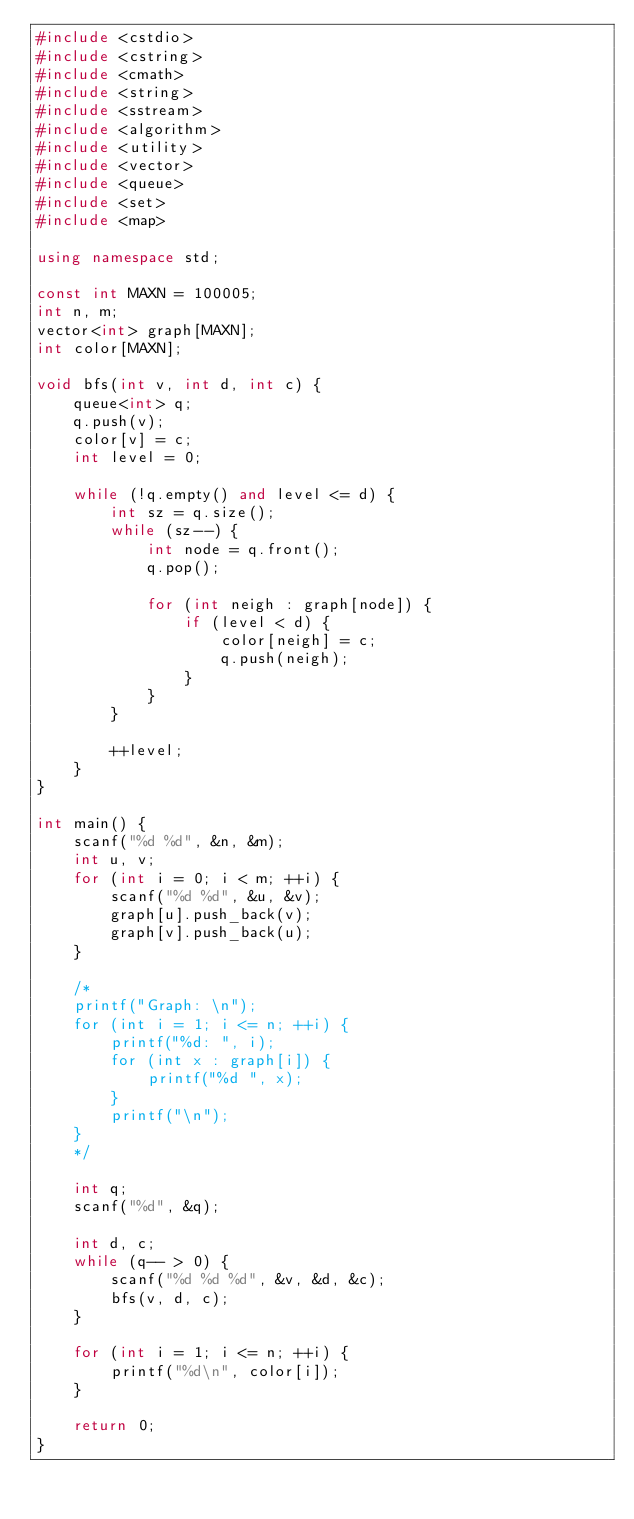Convert code to text. <code><loc_0><loc_0><loc_500><loc_500><_C++_>#include <cstdio>
#include <cstring>
#include <cmath>
#include <string>
#include <sstream>
#include <algorithm>
#include <utility>
#include <vector>
#include <queue>
#include <set>
#include <map>

using namespace std;

const int MAXN = 100005;
int n, m;
vector<int> graph[MAXN];
int color[MAXN];

void bfs(int v, int d, int c) {
    queue<int> q;
    q.push(v);
    color[v] = c;
    int level = 0;

    while (!q.empty() and level <= d) {
        int sz = q.size();
        while (sz--) {
            int node = q.front();
            q.pop();

            for (int neigh : graph[node]) {
                if (level < d) {
                    color[neigh] = c;
                    q.push(neigh);
                }
            }
        }

        ++level;
    }
}

int main() {
    scanf("%d %d", &n, &m);
    int u, v;
    for (int i = 0; i < m; ++i) {
        scanf("%d %d", &u, &v);
        graph[u].push_back(v);
        graph[v].push_back(u);
    }

    /*
    printf("Graph: \n");
    for (int i = 1; i <= n; ++i) {
        printf("%d: ", i);
        for (int x : graph[i]) {
            printf("%d ", x);
        }
        printf("\n");
    }
    */

    int q;
    scanf("%d", &q);

    int d, c;
    while (q-- > 0) {
        scanf("%d %d %d", &v, &d, &c);
        bfs(v, d, c);
    }

    for (int i = 1; i <= n; ++i) {
        printf("%d\n", color[i]);
    }

    return 0;
}
</code> 